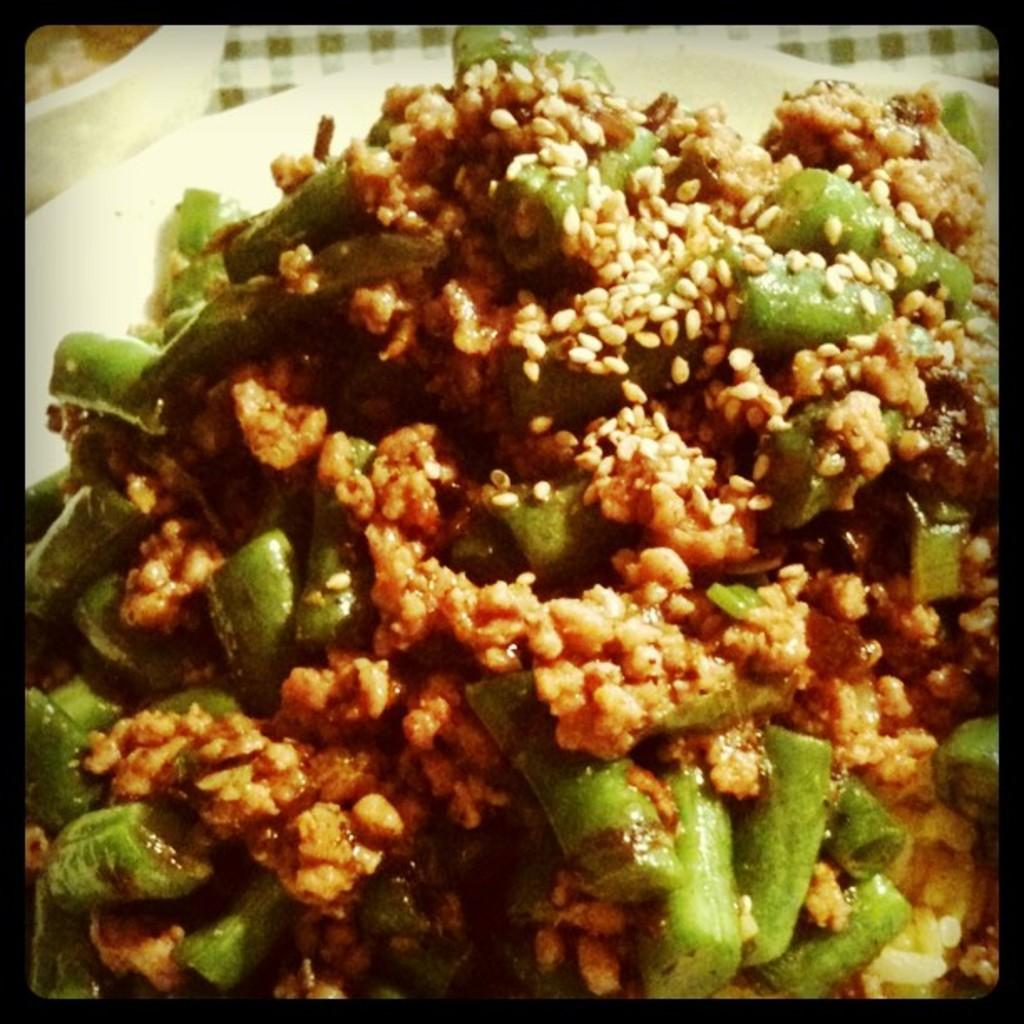What is in the bowl that is visible in the image? There is a bowl with food items in the image. What type of finger can be seen wearing jeans while sitting on a sofa in the image? There is no finger, jeans, or sofa present in the image; it only features a bowl with food items. 